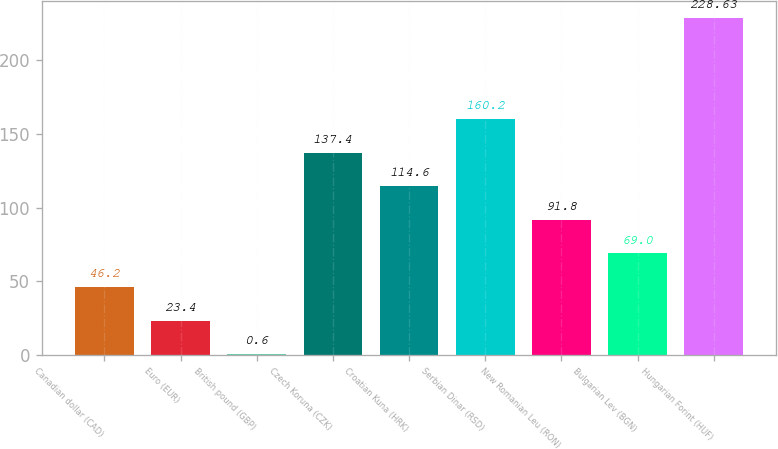<chart> <loc_0><loc_0><loc_500><loc_500><bar_chart><fcel>Canadian dollar (CAD)<fcel>Euro (EUR)<fcel>British pound (GBP)<fcel>Czech Koruna (CZK)<fcel>Croatian Kuna (HRK)<fcel>Serbian Dinar (RSD)<fcel>New Romanian Leu (RON)<fcel>Bulgarian Lev (BGN)<fcel>Hungarian Forint (HUF)<nl><fcel>46.2<fcel>23.4<fcel>0.6<fcel>137.4<fcel>114.6<fcel>160.2<fcel>91.8<fcel>69<fcel>228.63<nl></chart> 